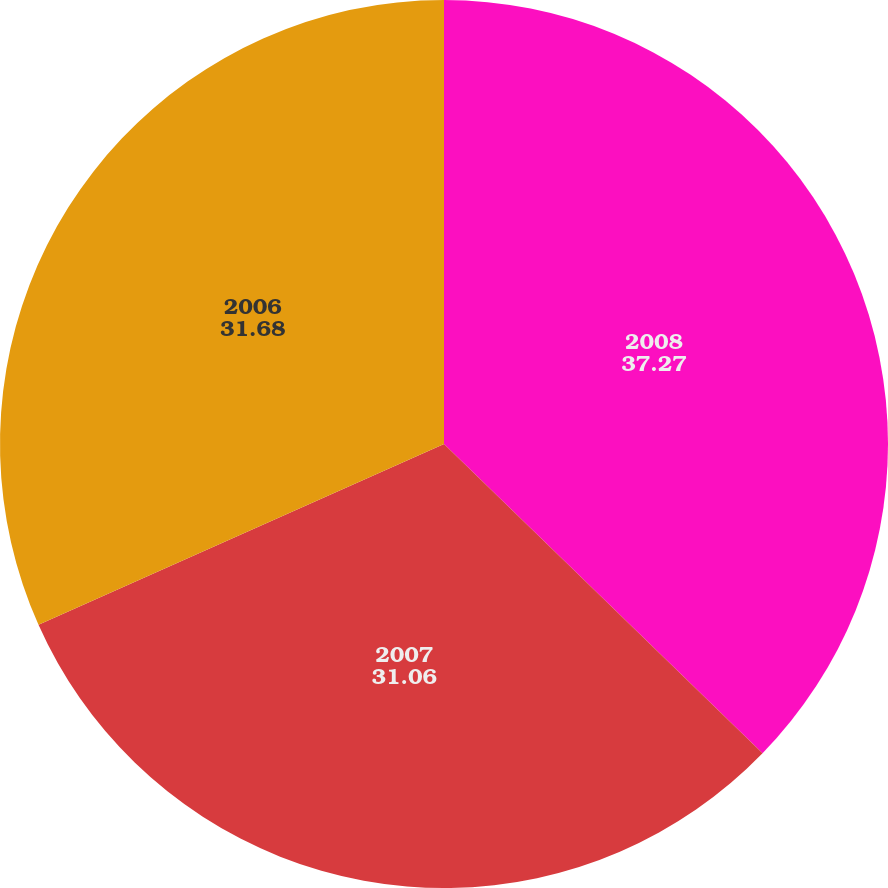<chart> <loc_0><loc_0><loc_500><loc_500><pie_chart><fcel>2008<fcel>2007<fcel>2006<nl><fcel>37.27%<fcel>31.06%<fcel>31.68%<nl></chart> 